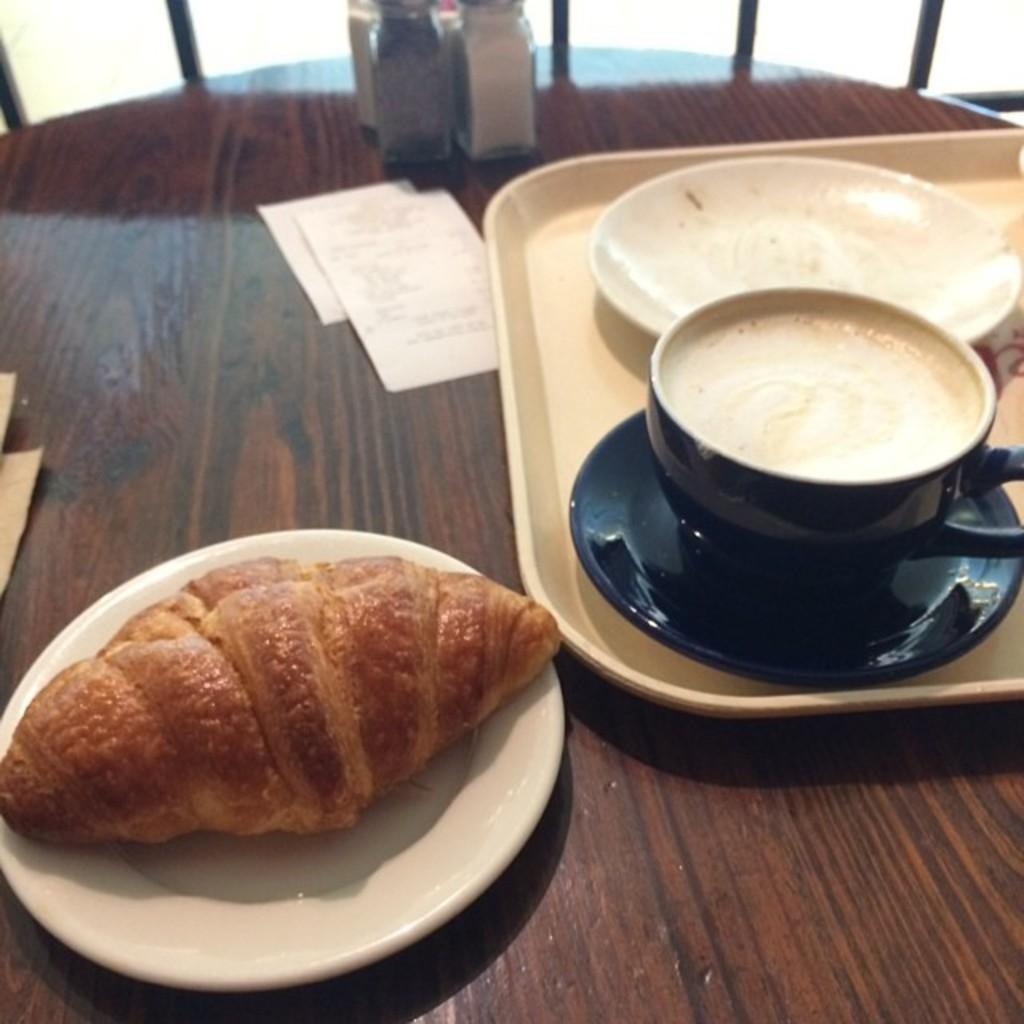What type of items can be seen on the table in the image? There is food and papers on the table in the image. What else is present in the image besides the table items? There are bottles and an empty plate in the image. Can you describe the color of any object in the image? Yes, there is an object that is black in color in the image. How does the cow contribute to the quiet atmosphere in the image? There is no cow present in the image, so it cannot contribute to the atmosphere. What process is being carried out in the image? The image does not depict a specific process; it shows food, papers, bottles, an empty plate, and a black object. 